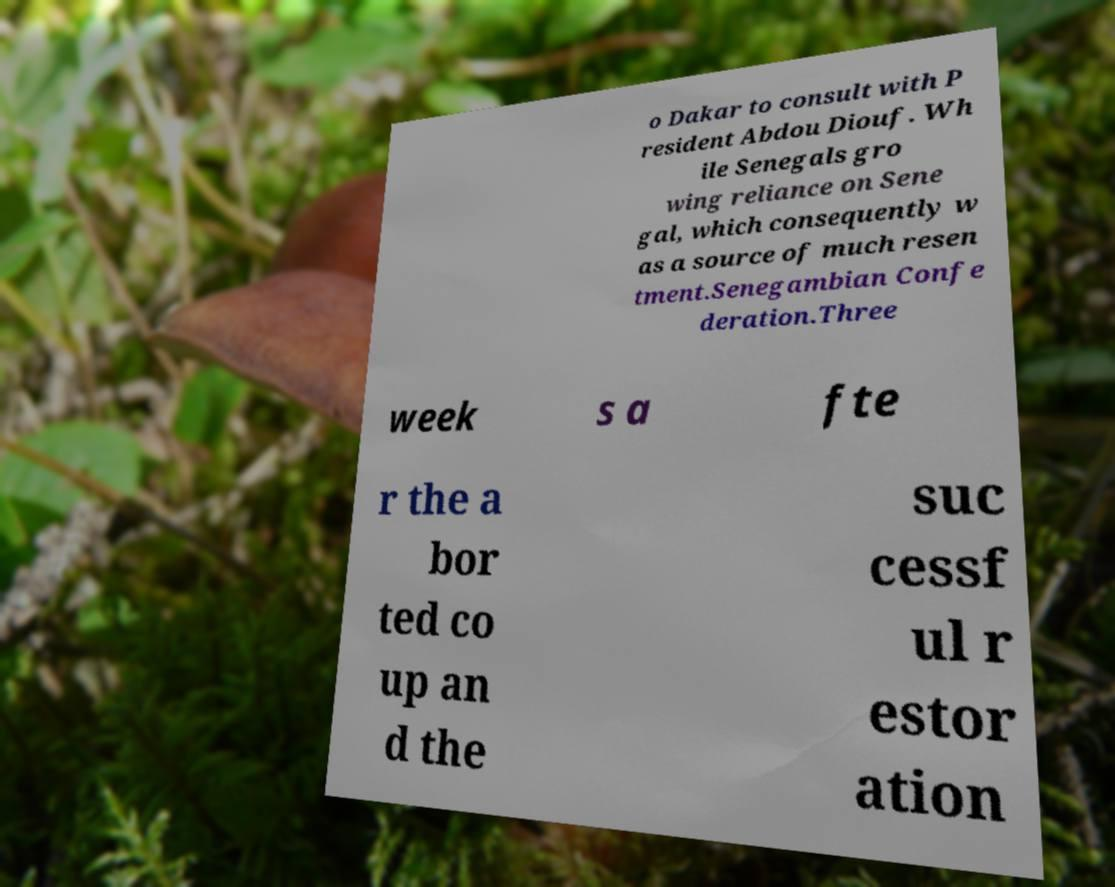Please identify and transcribe the text found in this image. o Dakar to consult with P resident Abdou Diouf. Wh ile Senegals gro wing reliance on Sene gal, which consequently w as a source of much resen tment.Senegambian Confe deration.Three week s a fte r the a bor ted co up an d the suc cessf ul r estor ation 